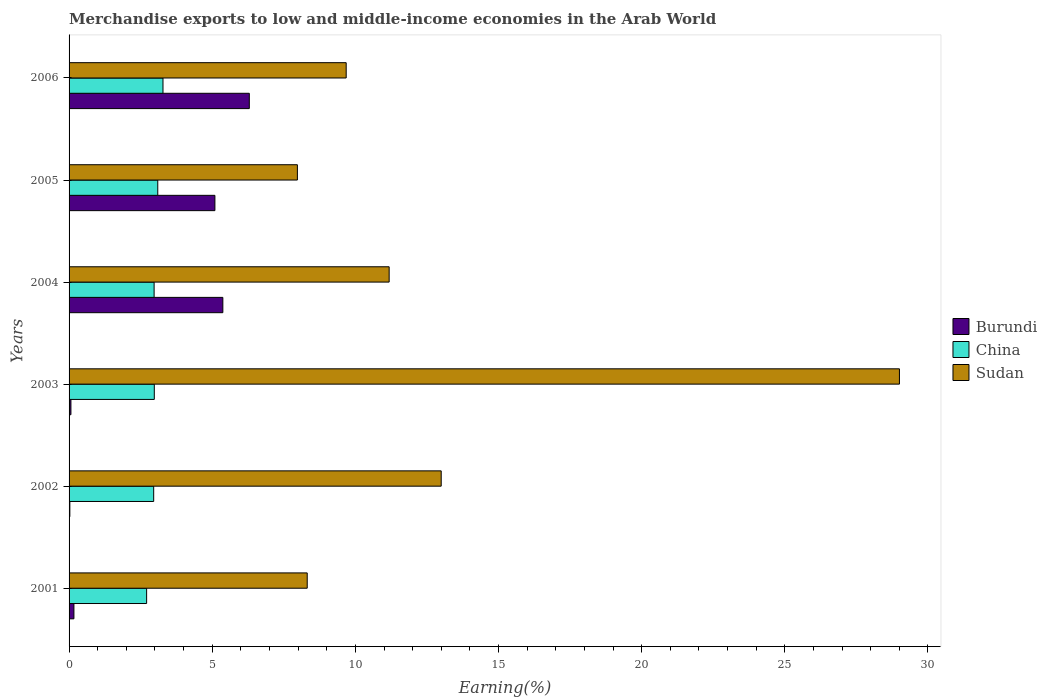How many groups of bars are there?
Your answer should be compact. 6. How many bars are there on the 1st tick from the bottom?
Make the answer very short. 3. What is the label of the 1st group of bars from the top?
Make the answer very short. 2006. What is the percentage of amount earned from merchandise exports in Burundi in 2004?
Offer a very short reply. 5.37. Across all years, what is the maximum percentage of amount earned from merchandise exports in Sudan?
Your answer should be compact. 29. Across all years, what is the minimum percentage of amount earned from merchandise exports in Burundi?
Ensure brevity in your answer.  0.03. In which year was the percentage of amount earned from merchandise exports in Burundi maximum?
Your response must be concise. 2006. In which year was the percentage of amount earned from merchandise exports in Sudan minimum?
Offer a very short reply. 2005. What is the total percentage of amount earned from merchandise exports in Burundi in the graph?
Offer a terse response. 17.02. What is the difference between the percentage of amount earned from merchandise exports in Burundi in 2003 and that in 2005?
Your answer should be very brief. -5.03. What is the difference between the percentage of amount earned from merchandise exports in Burundi in 2005 and the percentage of amount earned from merchandise exports in Sudan in 2003?
Offer a terse response. -23.91. What is the average percentage of amount earned from merchandise exports in Burundi per year?
Make the answer very short. 2.84. In the year 2001, what is the difference between the percentage of amount earned from merchandise exports in Sudan and percentage of amount earned from merchandise exports in China?
Ensure brevity in your answer.  5.61. In how many years, is the percentage of amount earned from merchandise exports in Burundi greater than 15 %?
Make the answer very short. 0. What is the ratio of the percentage of amount earned from merchandise exports in Burundi in 2003 to that in 2005?
Offer a terse response. 0.01. What is the difference between the highest and the second highest percentage of amount earned from merchandise exports in Burundi?
Make the answer very short. 0.92. What is the difference between the highest and the lowest percentage of amount earned from merchandise exports in Burundi?
Make the answer very short. 6.27. In how many years, is the percentage of amount earned from merchandise exports in Burundi greater than the average percentage of amount earned from merchandise exports in Burundi taken over all years?
Make the answer very short. 3. What does the 3rd bar from the top in 2003 represents?
Your answer should be very brief. Burundi. What does the 3rd bar from the bottom in 2002 represents?
Provide a short and direct response. Sudan. How many bars are there?
Your answer should be compact. 18. How many years are there in the graph?
Make the answer very short. 6. Does the graph contain any zero values?
Provide a short and direct response. No. Does the graph contain grids?
Offer a very short reply. No. Where does the legend appear in the graph?
Your answer should be compact. Center right. How many legend labels are there?
Your response must be concise. 3. How are the legend labels stacked?
Provide a short and direct response. Vertical. What is the title of the graph?
Offer a terse response. Merchandise exports to low and middle-income economies in the Arab World. Does "Lao PDR" appear as one of the legend labels in the graph?
Give a very brief answer. No. What is the label or title of the X-axis?
Make the answer very short. Earning(%). What is the Earning(%) of Burundi in 2001?
Keep it short and to the point. 0.17. What is the Earning(%) of China in 2001?
Give a very brief answer. 2.71. What is the Earning(%) of Sudan in 2001?
Provide a short and direct response. 8.32. What is the Earning(%) of Burundi in 2002?
Keep it short and to the point. 0.03. What is the Earning(%) in China in 2002?
Your answer should be compact. 2.96. What is the Earning(%) of Sudan in 2002?
Your response must be concise. 13. What is the Earning(%) of Burundi in 2003?
Offer a very short reply. 0.06. What is the Earning(%) in China in 2003?
Your answer should be very brief. 2.98. What is the Earning(%) in Sudan in 2003?
Ensure brevity in your answer.  29. What is the Earning(%) in Burundi in 2004?
Offer a terse response. 5.37. What is the Earning(%) in China in 2004?
Offer a very short reply. 2.97. What is the Earning(%) in Sudan in 2004?
Offer a terse response. 11.18. What is the Earning(%) in Burundi in 2005?
Provide a short and direct response. 5.09. What is the Earning(%) in China in 2005?
Offer a terse response. 3.1. What is the Earning(%) in Sudan in 2005?
Give a very brief answer. 7.97. What is the Earning(%) in Burundi in 2006?
Make the answer very short. 6.3. What is the Earning(%) of China in 2006?
Ensure brevity in your answer.  3.28. What is the Earning(%) of Sudan in 2006?
Provide a succinct answer. 9.68. Across all years, what is the maximum Earning(%) of Burundi?
Your answer should be compact. 6.3. Across all years, what is the maximum Earning(%) of China?
Your answer should be compact. 3.28. Across all years, what is the maximum Earning(%) of Sudan?
Offer a terse response. 29. Across all years, what is the minimum Earning(%) in Burundi?
Provide a short and direct response. 0.03. Across all years, what is the minimum Earning(%) in China?
Give a very brief answer. 2.71. Across all years, what is the minimum Earning(%) of Sudan?
Provide a short and direct response. 7.97. What is the total Earning(%) of Burundi in the graph?
Make the answer very short. 17.02. What is the total Earning(%) of China in the graph?
Make the answer very short. 17.99. What is the total Earning(%) of Sudan in the graph?
Your answer should be very brief. 79.15. What is the difference between the Earning(%) in Burundi in 2001 and that in 2002?
Give a very brief answer. 0.14. What is the difference between the Earning(%) of China in 2001 and that in 2002?
Make the answer very short. -0.25. What is the difference between the Earning(%) of Sudan in 2001 and that in 2002?
Make the answer very short. -4.68. What is the difference between the Earning(%) of Burundi in 2001 and that in 2003?
Keep it short and to the point. 0.1. What is the difference between the Earning(%) of China in 2001 and that in 2003?
Provide a succinct answer. -0.27. What is the difference between the Earning(%) of Sudan in 2001 and that in 2003?
Your answer should be very brief. -20.69. What is the difference between the Earning(%) of Burundi in 2001 and that in 2004?
Provide a short and direct response. -5.2. What is the difference between the Earning(%) in China in 2001 and that in 2004?
Provide a short and direct response. -0.26. What is the difference between the Earning(%) in Sudan in 2001 and that in 2004?
Provide a succinct answer. -2.86. What is the difference between the Earning(%) of Burundi in 2001 and that in 2005?
Your answer should be compact. -4.92. What is the difference between the Earning(%) of China in 2001 and that in 2005?
Your answer should be very brief. -0.39. What is the difference between the Earning(%) in Sudan in 2001 and that in 2005?
Your answer should be compact. 0.34. What is the difference between the Earning(%) in Burundi in 2001 and that in 2006?
Offer a very short reply. -6.13. What is the difference between the Earning(%) in China in 2001 and that in 2006?
Keep it short and to the point. -0.57. What is the difference between the Earning(%) in Sudan in 2001 and that in 2006?
Provide a succinct answer. -1.36. What is the difference between the Earning(%) of Burundi in 2002 and that in 2003?
Offer a very short reply. -0.04. What is the difference between the Earning(%) in China in 2002 and that in 2003?
Make the answer very short. -0.02. What is the difference between the Earning(%) in Sudan in 2002 and that in 2003?
Your answer should be compact. -16.01. What is the difference between the Earning(%) in Burundi in 2002 and that in 2004?
Offer a terse response. -5.34. What is the difference between the Earning(%) of China in 2002 and that in 2004?
Make the answer very short. -0.01. What is the difference between the Earning(%) of Sudan in 2002 and that in 2004?
Your answer should be very brief. 1.82. What is the difference between the Earning(%) of Burundi in 2002 and that in 2005?
Give a very brief answer. -5.07. What is the difference between the Earning(%) in China in 2002 and that in 2005?
Offer a terse response. -0.14. What is the difference between the Earning(%) of Sudan in 2002 and that in 2005?
Your answer should be very brief. 5.02. What is the difference between the Earning(%) in Burundi in 2002 and that in 2006?
Offer a very short reply. -6.27. What is the difference between the Earning(%) of China in 2002 and that in 2006?
Ensure brevity in your answer.  -0.32. What is the difference between the Earning(%) of Sudan in 2002 and that in 2006?
Make the answer very short. 3.32. What is the difference between the Earning(%) of Burundi in 2003 and that in 2004?
Provide a short and direct response. -5.31. What is the difference between the Earning(%) of China in 2003 and that in 2004?
Offer a terse response. 0.01. What is the difference between the Earning(%) of Sudan in 2003 and that in 2004?
Keep it short and to the point. 17.82. What is the difference between the Earning(%) in Burundi in 2003 and that in 2005?
Offer a very short reply. -5.03. What is the difference between the Earning(%) of China in 2003 and that in 2005?
Give a very brief answer. -0.12. What is the difference between the Earning(%) in Sudan in 2003 and that in 2005?
Offer a terse response. 21.03. What is the difference between the Earning(%) in Burundi in 2003 and that in 2006?
Offer a terse response. -6.23. What is the difference between the Earning(%) of China in 2003 and that in 2006?
Your response must be concise. -0.3. What is the difference between the Earning(%) of Sudan in 2003 and that in 2006?
Make the answer very short. 19.32. What is the difference between the Earning(%) in Burundi in 2004 and that in 2005?
Offer a very short reply. 0.28. What is the difference between the Earning(%) of China in 2004 and that in 2005?
Your response must be concise. -0.13. What is the difference between the Earning(%) of Sudan in 2004 and that in 2005?
Provide a succinct answer. 3.21. What is the difference between the Earning(%) of Burundi in 2004 and that in 2006?
Keep it short and to the point. -0.92. What is the difference between the Earning(%) of China in 2004 and that in 2006?
Your response must be concise. -0.31. What is the difference between the Earning(%) of Sudan in 2004 and that in 2006?
Provide a short and direct response. 1.5. What is the difference between the Earning(%) of Burundi in 2005 and that in 2006?
Give a very brief answer. -1.2. What is the difference between the Earning(%) in China in 2005 and that in 2006?
Provide a short and direct response. -0.18. What is the difference between the Earning(%) in Sudan in 2005 and that in 2006?
Offer a very short reply. -1.7. What is the difference between the Earning(%) in Burundi in 2001 and the Earning(%) in China in 2002?
Keep it short and to the point. -2.79. What is the difference between the Earning(%) in Burundi in 2001 and the Earning(%) in Sudan in 2002?
Offer a very short reply. -12.83. What is the difference between the Earning(%) of China in 2001 and the Earning(%) of Sudan in 2002?
Provide a short and direct response. -10.29. What is the difference between the Earning(%) of Burundi in 2001 and the Earning(%) of China in 2003?
Your answer should be very brief. -2.81. What is the difference between the Earning(%) in Burundi in 2001 and the Earning(%) in Sudan in 2003?
Your answer should be compact. -28.83. What is the difference between the Earning(%) in China in 2001 and the Earning(%) in Sudan in 2003?
Provide a succinct answer. -26.29. What is the difference between the Earning(%) in Burundi in 2001 and the Earning(%) in China in 2004?
Your response must be concise. -2.8. What is the difference between the Earning(%) of Burundi in 2001 and the Earning(%) of Sudan in 2004?
Offer a terse response. -11.01. What is the difference between the Earning(%) in China in 2001 and the Earning(%) in Sudan in 2004?
Make the answer very short. -8.47. What is the difference between the Earning(%) of Burundi in 2001 and the Earning(%) of China in 2005?
Give a very brief answer. -2.93. What is the difference between the Earning(%) in Burundi in 2001 and the Earning(%) in Sudan in 2005?
Your response must be concise. -7.81. What is the difference between the Earning(%) in China in 2001 and the Earning(%) in Sudan in 2005?
Your response must be concise. -5.27. What is the difference between the Earning(%) in Burundi in 2001 and the Earning(%) in China in 2006?
Your answer should be very brief. -3.11. What is the difference between the Earning(%) in Burundi in 2001 and the Earning(%) in Sudan in 2006?
Your response must be concise. -9.51. What is the difference between the Earning(%) in China in 2001 and the Earning(%) in Sudan in 2006?
Offer a very short reply. -6.97. What is the difference between the Earning(%) of Burundi in 2002 and the Earning(%) of China in 2003?
Give a very brief answer. -2.95. What is the difference between the Earning(%) in Burundi in 2002 and the Earning(%) in Sudan in 2003?
Provide a succinct answer. -28.98. What is the difference between the Earning(%) in China in 2002 and the Earning(%) in Sudan in 2003?
Make the answer very short. -26.05. What is the difference between the Earning(%) in Burundi in 2002 and the Earning(%) in China in 2004?
Give a very brief answer. -2.94. What is the difference between the Earning(%) in Burundi in 2002 and the Earning(%) in Sudan in 2004?
Offer a very short reply. -11.15. What is the difference between the Earning(%) of China in 2002 and the Earning(%) of Sudan in 2004?
Give a very brief answer. -8.22. What is the difference between the Earning(%) in Burundi in 2002 and the Earning(%) in China in 2005?
Your answer should be compact. -3.07. What is the difference between the Earning(%) of Burundi in 2002 and the Earning(%) of Sudan in 2005?
Keep it short and to the point. -7.95. What is the difference between the Earning(%) in China in 2002 and the Earning(%) in Sudan in 2005?
Ensure brevity in your answer.  -5.02. What is the difference between the Earning(%) in Burundi in 2002 and the Earning(%) in China in 2006?
Give a very brief answer. -3.25. What is the difference between the Earning(%) of Burundi in 2002 and the Earning(%) of Sudan in 2006?
Give a very brief answer. -9.65. What is the difference between the Earning(%) in China in 2002 and the Earning(%) in Sudan in 2006?
Offer a very short reply. -6.72. What is the difference between the Earning(%) of Burundi in 2003 and the Earning(%) of China in 2004?
Give a very brief answer. -2.91. What is the difference between the Earning(%) in Burundi in 2003 and the Earning(%) in Sudan in 2004?
Your response must be concise. -11.12. What is the difference between the Earning(%) in China in 2003 and the Earning(%) in Sudan in 2004?
Ensure brevity in your answer.  -8.2. What is the difference between the Earning(%) in Burundi in 2003 and the Earning(%) in China in 2005?
Give a very brief answer. -3.03. What is the difference between the Earning(%) in Burundi in 2003 and the Earning(%) in Sudan in 2005?
Provide a succinct answer. -7.91. What is the difference between the Earning(%) in China in 2003 and the Earning(%) in Sudan in 2005?
Offer a very short reply. -5. What is the difference between the Earning(%) of Burundi in 2003 and the Earning(%) of China in 2006?
Keep it short and to the point. -3.22. What is the difference between the Earning(%) in Burundi in 2003 and the Earning(%) in Sudan in 2006?
Give a very brief answer. -9.61. What is the difference between the Earning(%) of China in 2003 and the Earning(%) of Sudan in 2006?
Your answer should be compact. -6.7. What is the difference between the Earning(%) in Burundi in 2004 and the Earning(%) in China in 2005?
Make the answer very short. 2.27. What is the difference between the Earning(%) in Burundi in 2004 and the Earning(%) in Sudan in 2005?
Your response must be concise. -2.6. What is the difference between the Earning(%) in China in 2004 and the Earning(%) in Sudan in 2005?
Your answer should be compact. -5. What is the difference between the Earning(%) in Burundi in 2004 and the Earning(%) in China in 2006?
Offer a terse response. 2.09. What is the difference between the Earning(%) of Burundi in 2004 and the Earning(%) of Sudan in 2006?
Provide a short and direct response. -4.31. What is the difference between the Earning(%) in China in 2004 and the Earning(%) in Sudan in 2006?
Your response must be concise. -6.71. What is the difference between the Earning(%) in Burundi in 2005 and the Earning(%) in China in 2006?
Your answer should be very brief. 1.81. What is the difference between the Earning(%) of Burundi in 2005 and the Earning(%) of Sudan in 2006?
Give a very brief answer. -4.59. What is the difference between the Earning(%) in China in 2005 and the Earning(%) in Sudan in 2006?
Your answer should be very brief. -6.58. What is the average Earning(%) of Burundi per year?
Offer a very short reply. 2.84. What is the average Earning(%) in China per year?
Make the answer very short. 3. What is the average Earning(%) in Sudan per year?
Keep it short and to the point. 13.19. In the year 2001, what is the difference between the Earning(%) of Burundi and Earning(%) of China?
Keep it short and to the point. -2.54. In the year 2001, what is the difference between the Earning(%) of Burundi and Earning(%) of Sudan?
Offer a very short reply. -8.15. In the year 2001, what is the difference between the Earning(%) in China and Earning(%) in Sudan?
Give a very brief answer. -5.61. In the year 2002, what is the difference between the Earning(%) in Burundi and Earning(%) in China?
Make the answer very short. -2.93. In the year 2002, what is the difference between the Earning(%) of Burundi and Earning(%) of Sudan?
Provide a succinct answer. -12.97. In the year 2002, what is the difference between the Earning(%) of China and Earning(%) of Sudan?
Provide a short and direct response. -10.04. In the year 2003, what is the difference between the Earning(%) of Burundi and Earning(%) of China?
Your answer should be compact. -2.91. In the year 2003, what is the difference between the Earning(%) of Burundi and Earning(%) of Sudan?
Offer a very short reply. -28.94. In the year 2003, what is the difference between the Earning(%) in China and Earning(%) in Sudan?
Offer a very short reply. -26.03. In the year 2004, what is the difference between the Earning(%) in Burundi and Earning(%) in China?
Provide a short and direct response. 2.4. In the year 2004, what is the difference between the Earning(%) of Burundi and Earning(%) of Sudan?
Give a very brief answer. -5.81. In the year 2004, what is the difference between the Earning(%) of China and Earning(%) of Sudan?
Provide a short and direct response. -8.21. In the year 2005, what is the difference between the Earning(%) in Burundi and Earning(%) in China?
Make the answer very short. 2. In the year 2005, what is the difference between the Earning(%) of Burundi and Earning(%) of Sudan?
Make the answer very short. -2.88. In the year 2005, what is the difference between the Earning(%) in China and Earning(%) in Sudan?
Provide a succinct answer. -4.88. In the year 2006, what is the difference between the Earning(%) of Burundi and Earning(%) of China?
Your response must be concise. 3.02. In the year 2006, what is the difference between the Earning(%) in Burundi and Earning(%) in Sudan?
Make the answer very short. -3.38. In the year 2006, what is the difference between the Earning(%) of China and Earning(%) of Sudan?
Provide a succinct answer. -6.4. What is the ratio of the Earning(%) of Burundi in 2001 to that in 2002?
Provide a short and direct response. 6.27. What is the ratio of the Earning(%) in China in 2001 to that in 2002?
Provide a short and direct response. 0.92. What is the ratio of the Earning(%) in Sudan in 2001 to that in 2002?
Offer a terse response. 0.64. What is the ratio of the Earning(%) of Burundi in 2001 to that in 2003?
Your answer should be compact. 2.62. What is the ratio of the Earning(%) in China in 2001 to that in 2003?
Provide a succinct answer. 0.91. What is the ratio of the Earning(%) in Sudan in 2001 to that in 2003?
Offer a very short reply. 0.29. What is the ratio of the Earning(%) of Burundi in 2001 to that in 2004?
Provide a short and direct response. 0.03. What is the ratio of the Earning(%) in China in 2001 to that in 2004?
Offer a very short reply. 0.91. What is the ratio of the Earning(%) of Sudan in 2001 to that in 2004?
Your response must be concise. 0.74. What is the ratio of the Earning(%) in China in 2001 to that in 2005?
Keep it short and to the point. 0.87. What is the ratio of the Earning(%) in Sudan in 2001 to that in 2005?
Offer a very short reply. 1.04. What is the ratio of the Earning(%) of Burundi in 2001 to that in 2006?
Ensure brevity in your answer.  0.03. What is the ratio of the Earning(%) of China in 2001 to that in 2006?
Your response must be concise. 0.83. What is the ratio of the Earning(%) of Sudan in 2001 to that in 2006?
Ensure brevity in your answer.  0.86. What is the ratio of the Earning(%) in Burundi in 2002 to that in 2003?
Give a very brief answer. 0.42. What is the ratio of the Earning(%) in Sudan in 2002 to that in 2003?
Provide a succinct answer. 0.45. What is the ratio of the Earning(%) in Burundi in 2002 to that in 2004?
Offer a very short reply. 0.01. What is the ratio of the Earning(%) in China in 2002 to that in 2004?
Ensure brevity in your answer.  1. What is the ratio of the Earning(%) of Sudan in 2002 to that in 2004?
Provide a short and direct response. 1.16. What is the ratio of the Earning(%) in Burundi in 2002 to that in 2005?
Provide a succinct answer. 0.01. What is the ratio of the Earning(%) of China in 2002 to that in 2005?
Ensure brevity in your answer.  0.95. What is the ratio of the Earning(%) of Sudan in 2002 to that in 2005?
Keep it short and to the point. 1.63. What is the ratio of the Earning(%) in Burundi in 2002 to that in 2006?
Provide a short and direct response. 0. What is the ratio of the Earning(%) of China in 2002 to that in 2006?
Your answer should be compact. 0.9. What is the ratio of the Earning(%) of Sudan in 2002 to that in 2006?
Your answer should be very brief. 1.34. What is the ratio of the Earning(%) of Burundi in 2003 to that in 2004?
Make the answer very short. 0.01. What is the ratio of the Earning(%) in China in 2003 to that in 2004?
Your response must be concise. 1. What is the ratio of the Earning(%) in Sudan in 2003 to that in 2004?
Your response must be concise. 2.59. What is the ratio of the Earning(%) of Burundi in 2003 to that in 2005?
Keep it short and to the point. 0.01. What is the ratio of the Earning(%) in Sudan in 2003 to that in 2005?
Make the answer very short. 3.64. What is the ratio of the Earning(%) in Burundi in 2003 to that in 2006?
Ensure brevity in your answer.  0.01. What is the ratio of the Earning(%) in China in 2003 to that in 2006?
Offer a terse response. 0.91. What is the ratio of the Earning(%) of Sudan in 2003 to that in 2006?
Ensure brevity in your answer.  3. What is the ratio of the Earning(%) of Burundi in 2004 to that in 2005?
Your response must be concise. 1.05. What is the ratio of the Earning(%) in China in 2004 to that in 2005?
Provide a succinct answer. 0.96. What is the ratio of the Earning(%) of Sudan in 2004 to that in 2005?
Provide a succinct answer. 1.4. What is the ratio of the Earning(%) in Burundi in 2004 to that in 2006?
Make the answer very short. 0.85. What is the ratio of the Earning(%) in China in 2004 to that in 2006?
Provide a succinct answer. 0.91. What is the ratio of the Earning(%) of Sudan in 2004 to that in 2006?
Offer a terse response. 1.16. What is the ratio of the Earning(%) of Burundi in 2005 to that in 2006?
Your response must be concise. 0.81. What is the ratio of the Earning(%) in China in 2005 to that in 2006?
Your answer should be compact. 0.94. What is the ratio of the Earning(%) in Sudan in 2005 to that in 2006?
Your response must be concise. 0.82. What is the difference between the highest and the second highest Earning(%) in Burundi?
Provide a succinct answer. 0.92. What is the difference between the highest and the second highest Earning(%) in China?
Your answer should be compact. 0.18. What is the difference between the highest and the second highest Earning(%) of Sudan?
Make the answer very short. 16.01. What is the difference between the highest and the lowest Earning(%) in Burundi?
Your response must be concise. 6.27. What is the difference between the highest and the lowest Earning(%) in China?
Offer a terse response. 0.57. What is the difference between the highest and the lowest Earning(%) in Sudan?
Keep it short and to the point. 21.03. 